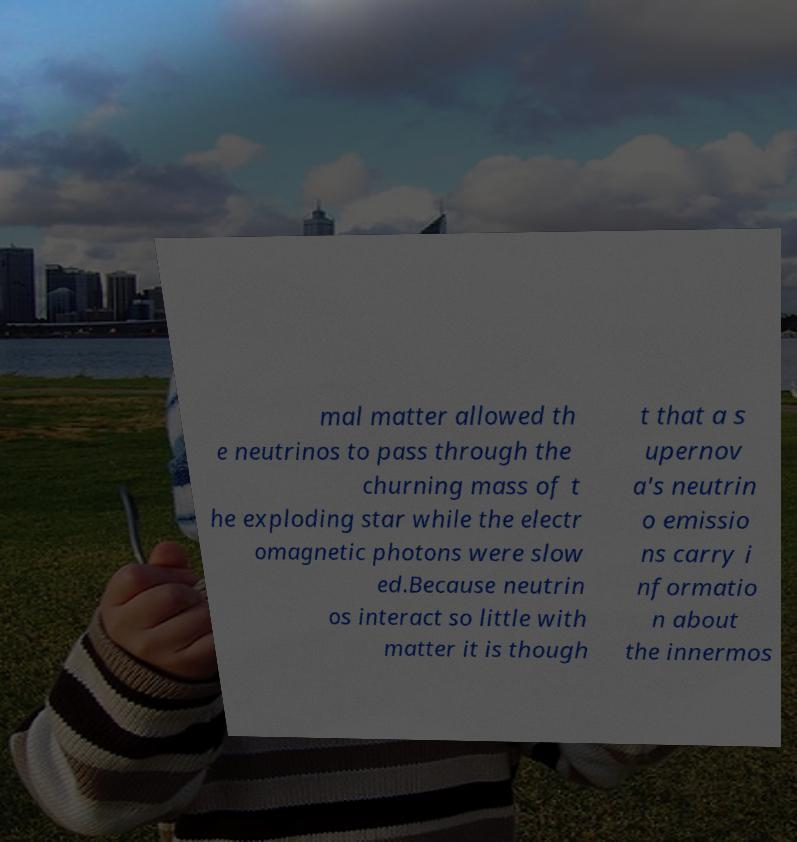Could you extract and type out the text from this image? mal matter allowed th e neutrinos to pass through the churning mass of t he exploding star while the electr omagnetic photons were slow ed.Because neutrin os interact so little with matter it is though t that a s upernov a's neutrin o emissio ns carry i nformatio n about the innermos 